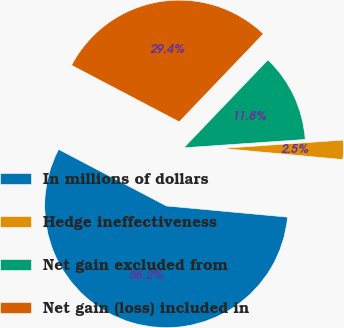<chart> <loc_0><loc_0><loc_500><loc_500><pie_chart><fcel>In millions of dollars<fcel>Hedge ineffectiveness<fcel>Net gain excluded from<fcel>Net gain (loss) included in<nl><fcel>56.23%<fcel>2.55%<fcel>11.77%<fcel>29.45%<nl></chart> 